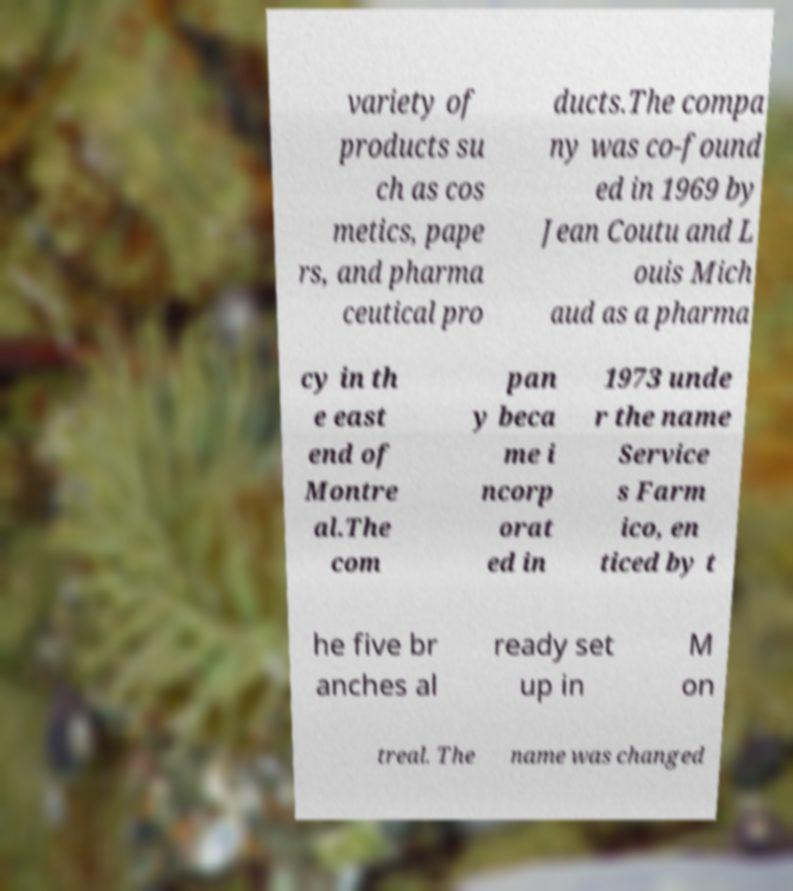There's text embedded in this image that I need extracted. Can you transcribe it verbatim? variety of products su ch as cos metics, pape rs, and pharma ceutical pro ducts.The compa ny was co-found ed in 1969 by Jean Coutu and L ouis Mich aud as a pharma cy in th e east end of Montre al.The com pan y beca me i ncorp orat ed in 1973 unde r the name Service s Farm ico, en ticed by t he five br anches al ready set up in M on treal. The name was changed 